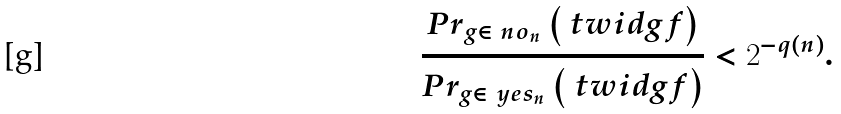Convert formula to latex. <formula><loc_0><loc_0><loc_500><loc_500>\frac { P r _ { g \in \ n o _ { n } } \left ( \ t w i d { g } { f } \right ) } { P r _ { g \in \ y e s _ { n } } \left ( \ t w i d { g } { f } \right ) } < 2 ^ { - q ( n ) } .</formula> 